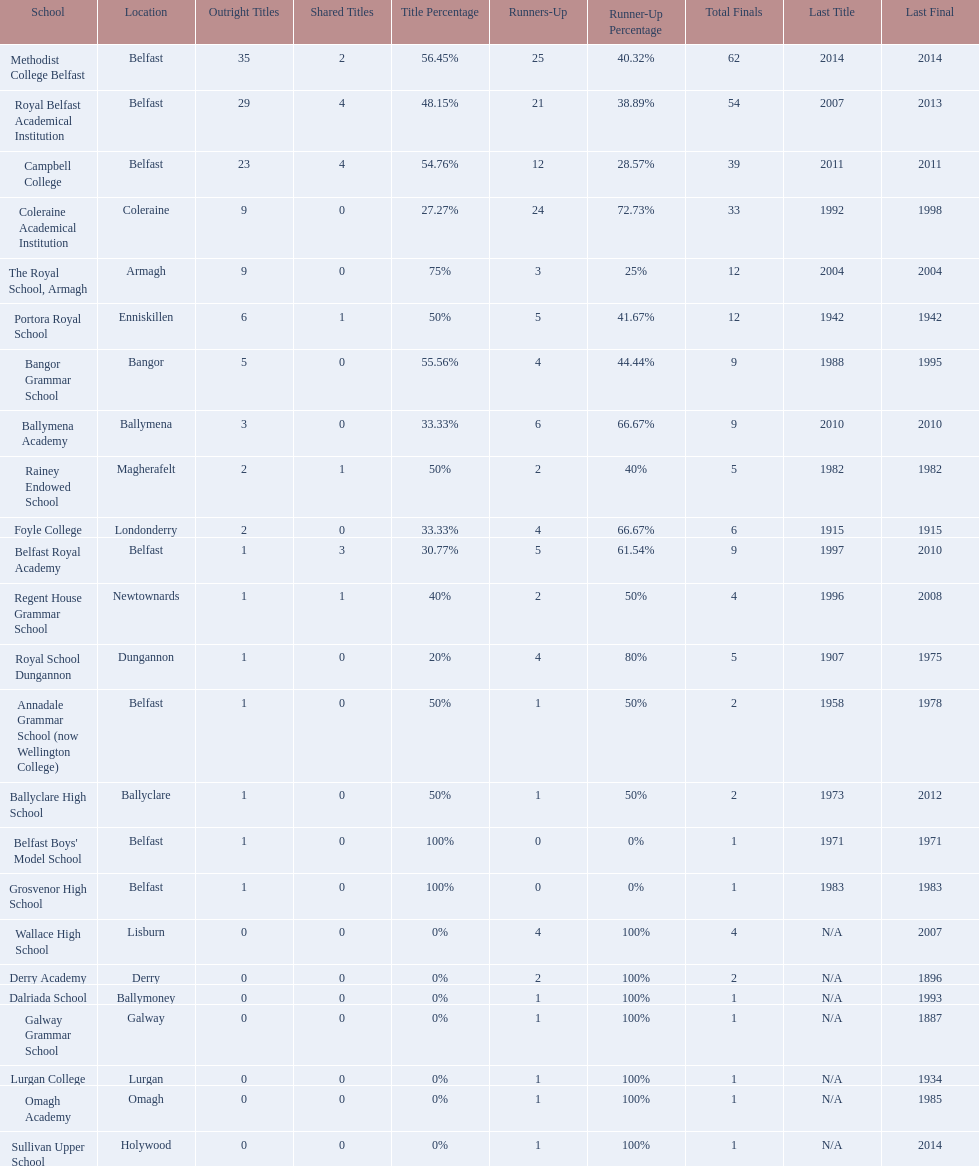Which colleges participated in the ulster's schools' cup? Methodist College Belfast, Royal Belfast Academical Institution, Campbell College, Coleraine Academical Institution, The Royal School, Armagh, Portora Royal School, Bangor Grammar School, Ballymena Academy, Rainey Endowed School, Foyle College, Belfast Royal Academy, Regent House Grammar School, Royal School Dungannon, Annadale Grammar School (now Wellington College), Ballyclare High School, Belfast Boys' Model School, Grosvenor High School, Wallace High School, Derry Academy, Dalriada School, Galway Grammar School, Lurgan College, Omagh Academy, Sullivan Upper School. Of these, which are from belfast? Methodist College Belfast, Royal Belfast Academical Institution, Campbell College, Belfast Royal Academy, Annadale Grammar School (now Wellington College), Belfast Boys' Model School, Grosvenor High School. Of these, which have more than 20 outright titles? Methodist College Belfast, Royal Belfast Academical Institution, Campbell College. Which of these have the fewest runners-up? Campbell College. 